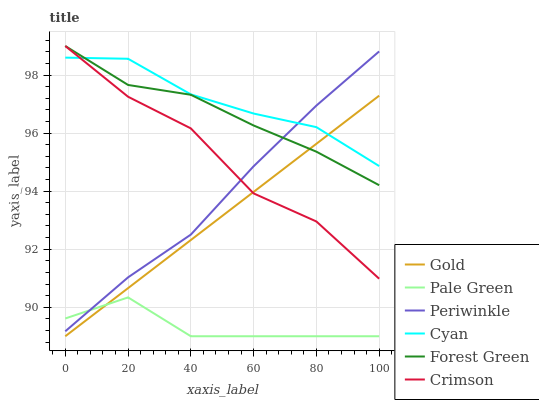Does Pale Green have the minimum area under the curve?
Answer yes or no. Yes. Does Cyan have the maximum area under the curve?
Answer yes or no. Yes. Does Forest Green have the minimum area under the curve?
Answer yes or no. No. Does Forest Green have the maximum area under the curve?
Answer yes or no. No. Is Gold the smoothest?
Answer yes or no. Yes. Is Crimson the roughest?
Answer yes or no. Yes. Is Forest Green the smoothest?
Answer yes or no. No. Is Forest Green the roughest?
Answer yes or no. No. Does Gold have the lowest value?
Answer yes or no. Yes. Does Forest Green have the lowest value?
Answer yes or no. No. Does Crimson have the highest value?
Answer yes or no. Yes. Does Pale Green have the highest value?
Answer yes or no. No. Is Pale Green less than Forest Green?
Answer yes or no. Yes. Is Cyan greater than Pale Green?
Answer yes or no. Yes. Does Cyan intersect Gold?
Answer yes or no. Yes. Is Cyan less than Gold?
Answer yes or no. No. Is Cyan greater than Gold?
Answer yes or no. No. Does Pale Green intersect Forest Green?
Answer yes or no. No. 